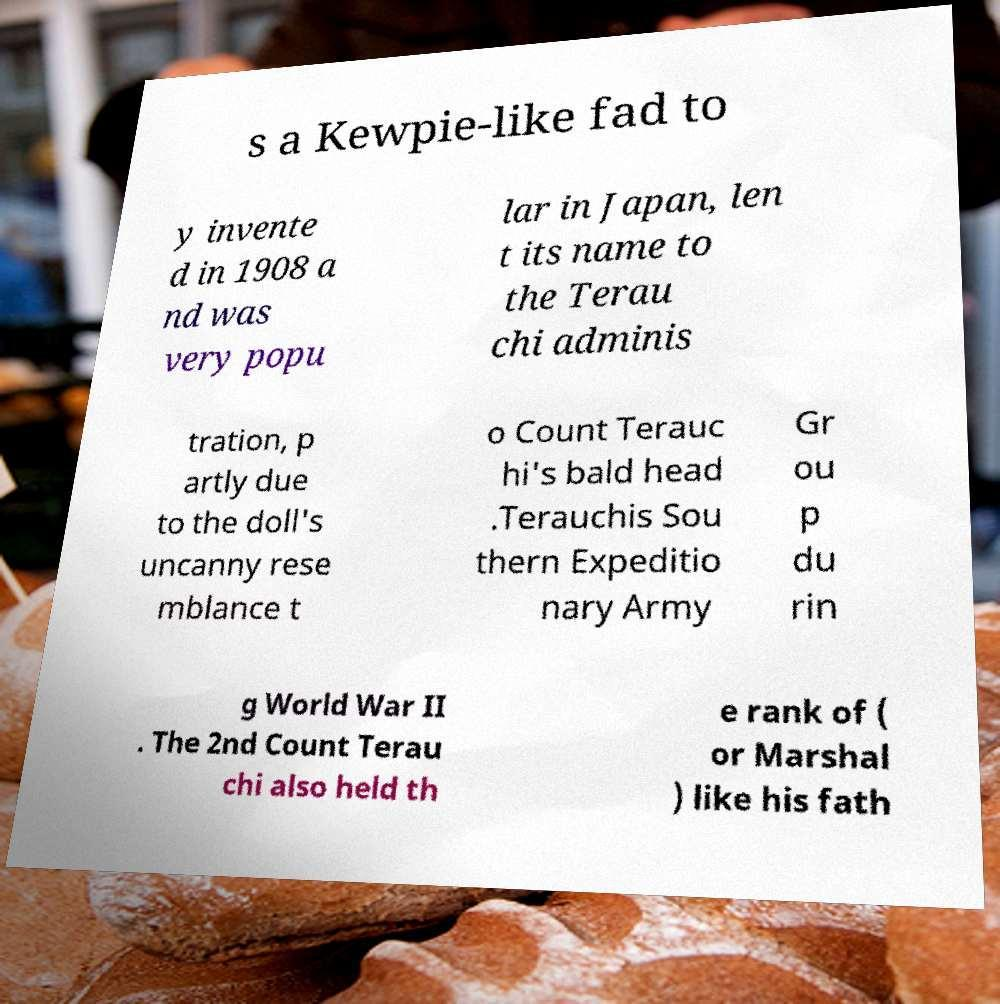There's text embedded in this image that I need extracted. Can you transcribe it verbatim? s a Kewpie-like fad to y invente d in 1908 a nd was very popu lar in Japan, len t its name to the Terau chi adminis tration, p artly due to the doll's uncanny rese mblance t o Count Terauc hi's bald head .Terauchis Sou thern Expeditio nary Army Gr ou p du rin g World War II . The 2nd Count Terau chi also held th e rank of ( or Marshal ) like his fath 